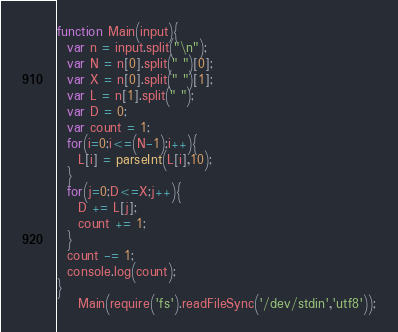<code> <loc_0><loc_0><loc_500><loc_500><_JavaScript_>function Main(input){
  var n = input.split("\n");
  var N = n[0].split(" ")[0];
  var X = n[0].split(" ")[1];
  var L = n[1].split(" ");
  var D = 0;
  var count = 1;
  for(i=0;i<=(N-1);i++){
    L[i] = parseInt(L[i],10);
  }
  for(j=0;D<=X;j++){
    D += L[j];
    count += 1;
  }
  count -= 1;
  console.log(count);
}
    Main(require('fs').readFileSync('/dev/stdin','utf8'));</code> 